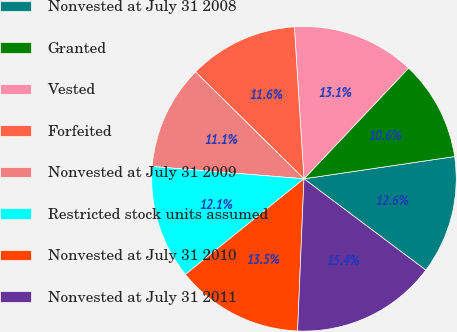<chart> <loc_0><loc_0><loc_500><loc_500><pie_chart><fcel>Nonvested at July 31 2008<fcel>Granted<fcel>Vested<fcel>Forfeited<fcel>Nonvested at July 31 2009<fcel>Restricted stock units assumed<fcel>Nonvested at July 31 2010<fcel>Nonvested at July 31 2011<nl><fcel>12.57%<fcel>10.62%<fcel>13.05%<fcel>11.61%<fcel>11.1%<fcel>12.09%<fcel>13.53%<fcel>15.43%<nl></chart> 